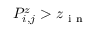<formula> <loc_0><loc_0><loc_500><loc_500>P _ { i , j } ^ { z } > z _ { i n }</formula> 